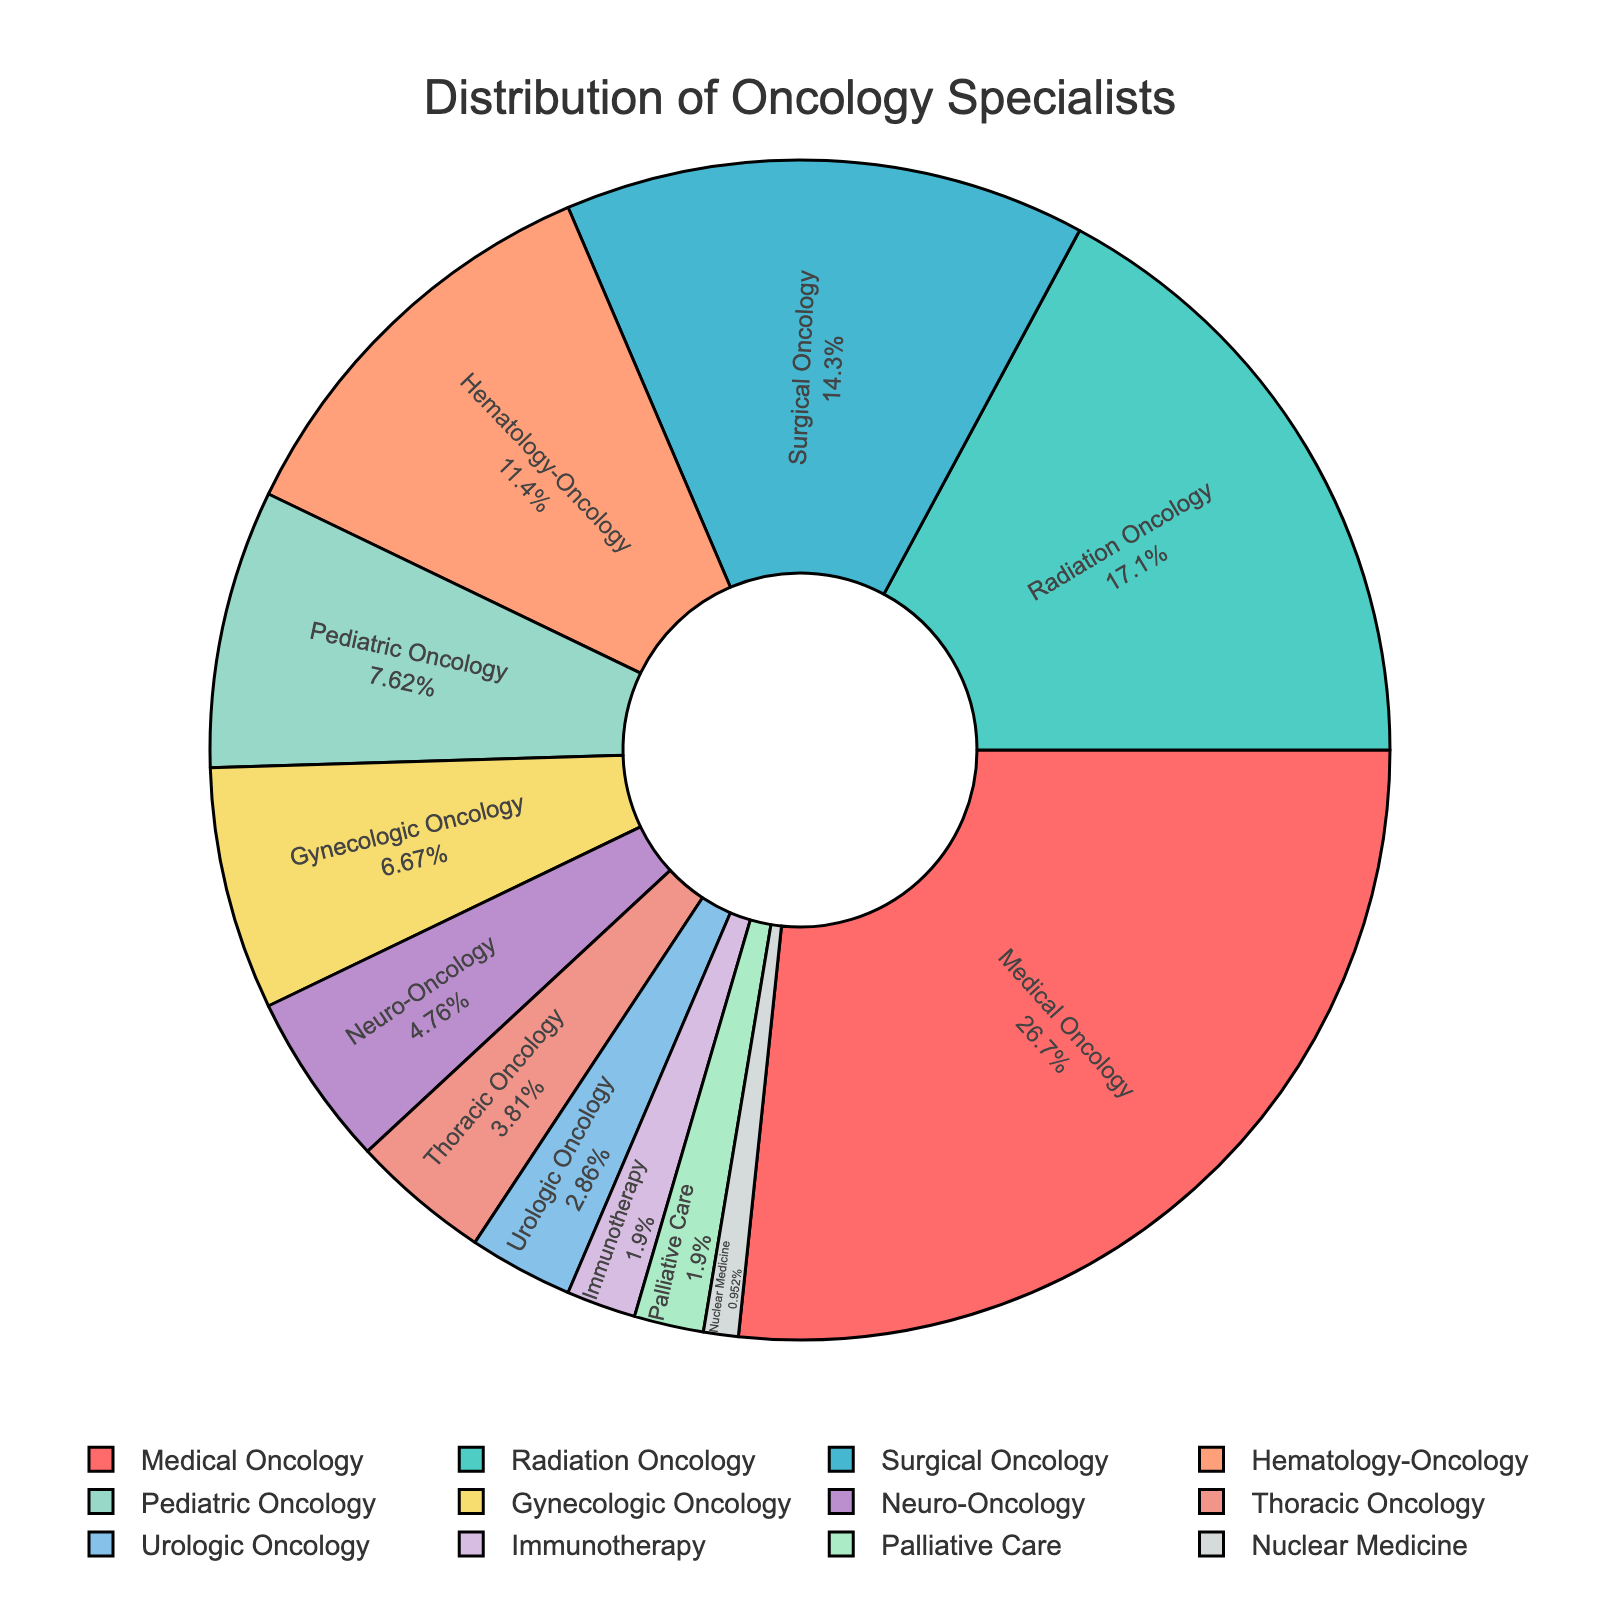Which specialty has the highest percentage of oncology specialists? Look at the pie chart and determine which segment is largest. The label for this segment is "Medical Oncology" and its percentage is 28%.
Answer: Medical Oncology Which two specialties combined have the same percentage of specialists as Radiation Oncology? Radiation Oncology has 18%. Pediatric Oncology (8%) and Gynecologic Oncology (7%) sum to 15%, which is close but not exact. Hematology-Oncology (12%) and Thoracic Oncology (4%) combine to 16%, also not exact. Surgical Oncology (15%) and Nuclear Medicine (1%) sum to 16%, still not 18%. Combining Surgical Oncology (15%) and Palliative Care (2%) gives 17%. Finally, Hematology-Oncology (12%) and Pediatric Oncology (8%) sum to 20%, over 18%. Therefore, the closest sums would be Pediatric Oncology (8%) + Gynecologic Oncology (7%) + Palliative Care (2%) which is 17%, the closest we can achieve without exceeding 18%.
Answer: Pediatric Oncology + Gynecologic Oncology + Palliative Care How much larger is Medical Oncology compared to Gynecologic Oncology? Medical Oncology has a percentage of 28% while Gynecologic Oncology has 7%. The difference between these percentages is 28% - 7% = 21%.
Answer: 21% What percentage of oncology specialists are in Neuro-Oncology, Urologic Oncology and Immunotherapy combined? Summing the percentages of Neuro-Oncology (5%), Urologic Oncology (3%), and Immunotherapy (2%) gives 5% + 3% + 2% = 10%.
Answer: 10% Which specialty has more specialists: Thoracic Oncology or Urologic Oncology? Look at the figures for Thoracic Oncology (4%) and Urologic Oncology (3%). Thoracic Oncology has a higher percentage than Urologic Oncology.
Answer: Thoracic Oncology What proportion of oncology specialists are in Pediatric Oncology compared to Hematology-Oncology? Pediatric Oncology includes 8% of specialists, while Hematology-Oncology has 12%. The proportion is 8% / 12% = 2/3.
Answer: 2/3 What fraction of the total is made up by Hematology-Oncology and Surgical Oncology? Hematology-Oncology is 12% and Surgical Oncology is 15%. Together, they make up 12% + 15% = 27%. So the fraction is 27/100 = 27%.
Answer: 27% Arrange the specialties Pediatric Oncology, Gynecologic Oncology, and Neuro-Oncology in descending order of their percentages. Pediatrics Oncology has 8%, Gynecologic Oncology has 7%, and Neuro-Oncology has 5%. The descending order, from highest to lowest, is Pediatric Oncology (8%), Gynecologic Oncology (7%), and Neuro-Oncology (5%).
Answer: Pediatric Oncology, Gynecologic Oncology, Neuro-Oncology What is the difference in percentage points between Pediatric Oncology and Surgical Oncology? Pediatric Oncology accounts for 8%, while Surgical Oncology accounts for 15%. The difference between these two percentages is 15% - 8% = 7%.
Answer: 7% 